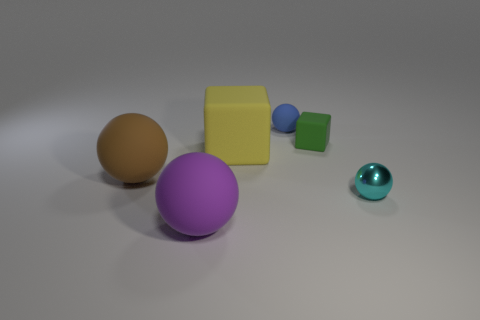Do the cyan shiny thing and the yellow matte thing have the same shape?
Make the answer very short. No. There is a thing that is in front of the blue matte ball and behind the big yellow rubber object; what material is it?
Offer a terse response. Rubber. How big is the cyan metallic ball?
Provide a succinct answer. Small. There is a tiny matte object that is the same shape as the small shiny object; what color is it?
Keep it short and to the point. Blue. Do the sphere in front of the tiny cyan sphere and the thing right of the tiny cube have the same size?
Ensure brevity in your answer.  No. Are there the same number of tiny metallic balls in front of the small cyan metal sphere and rubber spheres in front of the small blue rubber thing?
Your response must be concise. No. There is a blue matte object; does it have the same size as the thing that is on the left side of the large purple sphere?
Make the answer very short. No. There is a tiny ball that is on the left side of the cyan ball; is there a object that is left of it?
Keep it short and to the point. Yes. Are there any small red matte things that have the same shape as the large yellow object?
Your response must be concise. No. There is a rubber object to the right of the rubber object that is behind the green rubber object; what number of large rubber balls are right of it?
Your answer should be very brief. 0. 